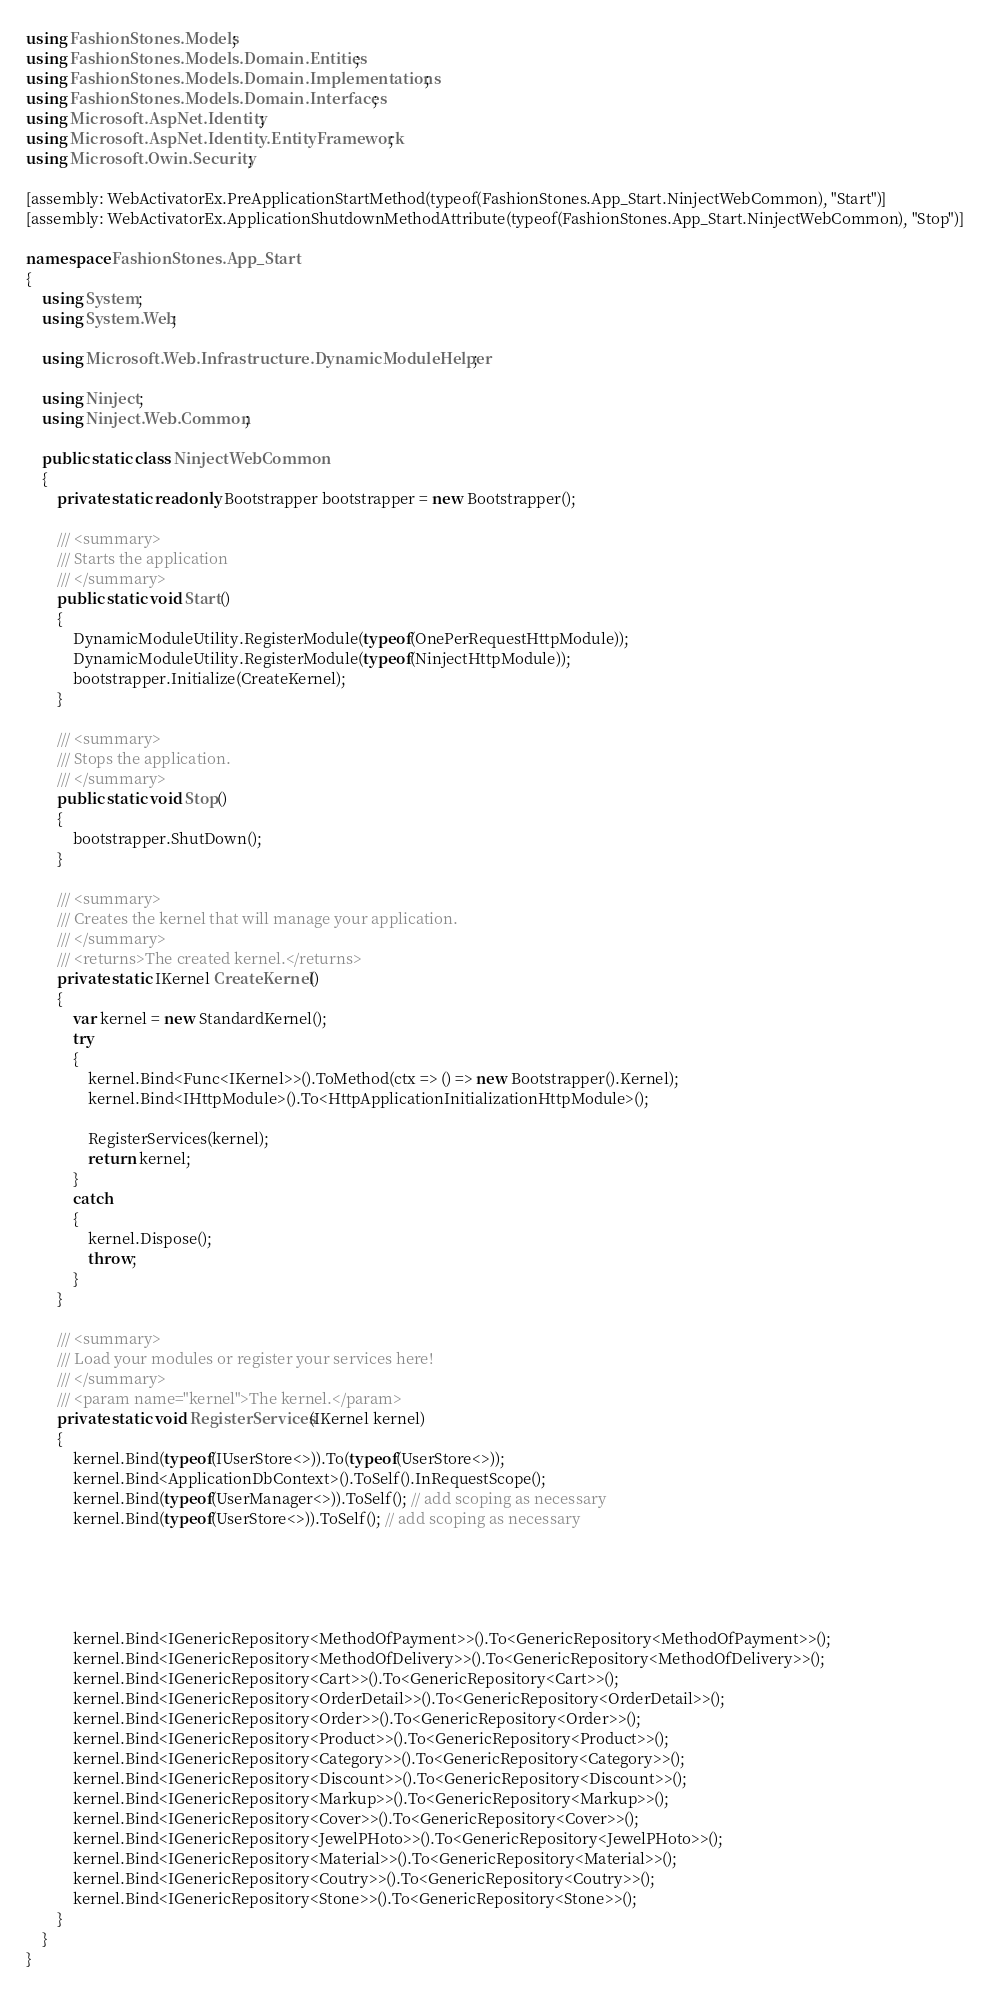<code> <loc_0><loc_0><loc_500><loc_500><_C#_>using FashionStones.Models;
using FashionStones.Models.Domain.Entities;
using FashionStones.Models.Domain.Implementations;
using FashionStones.Models.Domain.Interfaces;
using Microsoft.AspNet.Identity;
using Microsoft.AspNet.Identity.EntityFramework;
using Microsoft.Owin.Security;

[assembly: WebActivatorEx.PreApplicationStartMethod(typeof(FashionStones.App_Start.NinjectWebCommon), "Start")]
[assembly: WebActivatorEx.ApplicationShutdownMethodAttribute(typeof(FashionStones.App_Start.NinjectWebCommon), "Stop")]

namespace FashionStones.App_Start
{
    using System;
    using System.Web;

    using Microsoft.Web.Infrastructure.DynamicModuleHelper;

    using Ninject;
    using Ninject.Web.Common;

    public static class NinjectWebCommon 
    {
        private static readonly Bootstrapper bootstrapper = new Bootstrapper();

        /// <summary>
        /// Starts the application
        /// </summary>
        public static void Start() 
        {
            DynamicModuleUtility.RegisterModule(typeof(OnePerRequestHttpModule));
            DynamicModuleUtility.RegisterModule(typeof(NinjectHttpModule));
            bootstrapper.Initialize(CreateKernel);
        }
        
        /// <summary>
        /// Stops the application.
        /// </summary>
        public static void Stop()
        {
            bootstrapper.ShutDown();
        }
        
        /// <summary>
        /// Creates the kernel that will manage your application.
        /// </summary>
        /// <returns>The created kernel.</returns>
        private static IKernel CreateKernel()
        {
            var kernel = new StandardKernel();
            try
            {
                kernel.Bind<Func<IKernel>>().ToMethod(ctx => () => new Bootstrapper().Kernel);
                kernel.Bind<IHttpModule>().To<HttpApplicationInitializationHttpModule>();

                RegisterServices(kernel);
                return kernel;
            }
            catch
            {
                kernel.Dispose();
                throw;
            }
        }

        /// <summary>
        /// Load your modules or register your services here!
        /// </summary>
        /// <param name="kernel">The kernel.</param>
        private static void RegisterServices(IKernel kernel)
        {
            kernel.Bind(typeof(IUserStore<>)).To(typeof(UserStore<>));
            kernel.Bind<ApplicationDbContext>().ToSelf().InRequestScope();
            kernel.Bind(typeof(UserManager<>)).ToSelf(); // add scoping as necessary
            kernel.Bind(typeof(UserStore<>)).ToSelf(); // add scoping as necessary


            


            kernel.Bind<IGenericRepository<MethodOfPayment>>().To<GenericRepository<MethodOfPayment>>();
            kernel.Bind<IGenericRepository<MethodOfDelivery>>().To<GenericRepository<MethodOfDelivery>>();
            kernel.Bind<IGenericRepository<Cart>>().To<GenericRepository<Cart>>();
            kernel.Bind<IGenericRepository<OrderDetail>>().To<GenericRepository<OrderDetail>>();
            kernel.Bind<IGenericRepository<Order>>().To<GenericRepository<Order>>();
            kernel.Bind<IGenericRepository<Product>>().To<GenericRepository<Product>>();
            kernel.Bind<IGenericRepository<Category>>().To<GenericRepository<Category>>();
            kernel.Bind<IGenericRepository<Discount>>().To<GenericRepository<Discount>>();
            kernel.Bind<IGenericRepository<Markup>>().To<GenericRepository<Markup>>();
            kernel.Bind<IGenericRepository<Cover>>().To<GenericRepository<Cover>>();
            kernel.Bind<IGenericRepository<JewelPHoto>>().To<GenericRepository<JewelPHoto>>();
            kernel.Bind<IGenericRepository<Material>>().To<GenericRepository<Material>>();
            kernel.Bind<IGenericRepository<Coutry>>().To<GenericRepository<Coutry>>();
            kernel.Bind<IGenericRepository<Stone>>().To<GenericRepository<Stone>>();
        }        
    }
}
</code> 